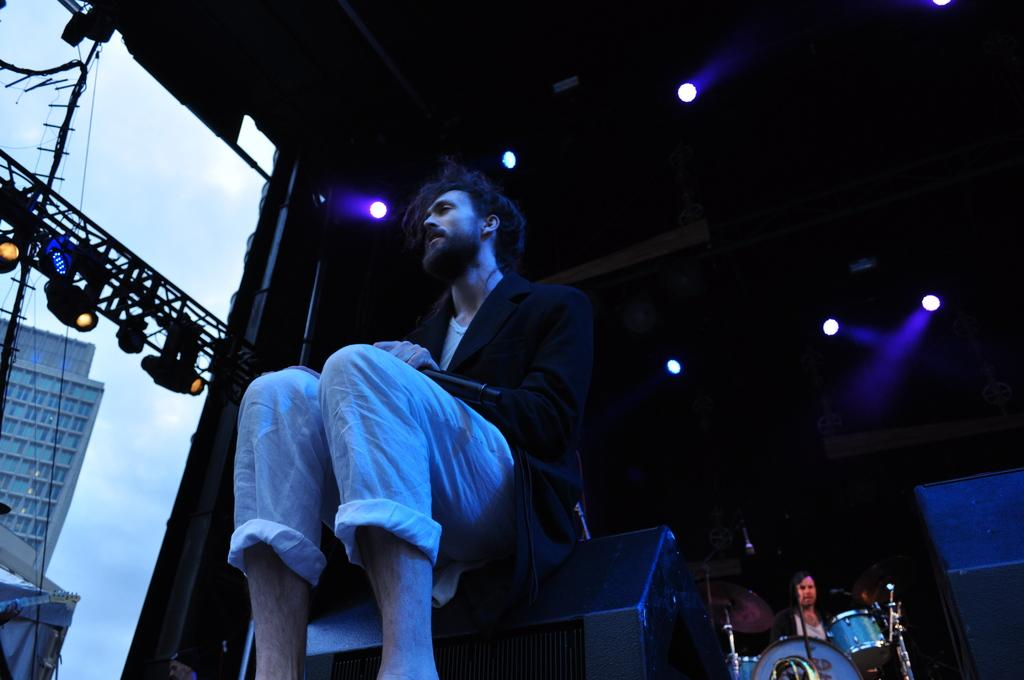Where was the image taken? The image was taken on a stage. What is the man in the black blazer doing in the image? The man in the black blazer is holding a microphone. What can be seen in the background of the image? There is another man playing a music instrument and a wall visible in the background. What type of advice does the carpenter give to the patient in the hospital in the image? There is no carpenter or patient in a hospital present in the image. 